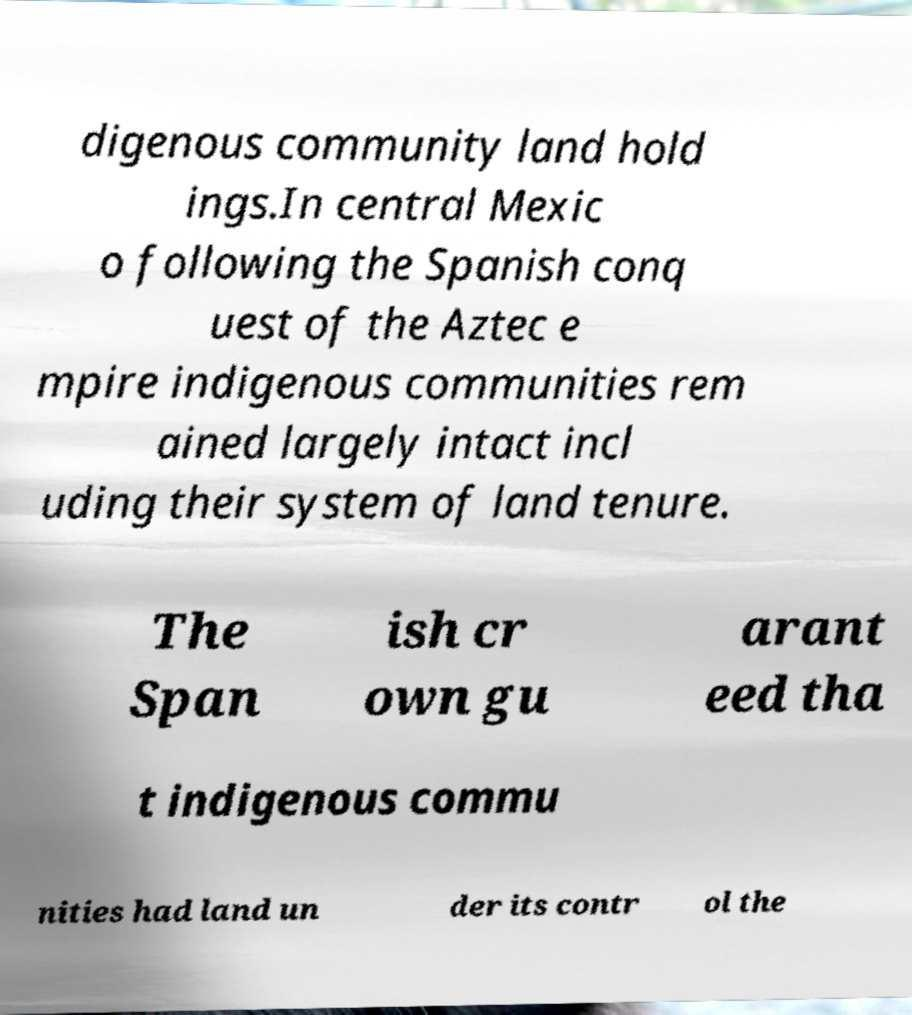Please read and relay the text visible in this image. What does it say? digenous community land hold ings.In central Mexic o following the Spanish conq uest of the Aztec e mpire indigenous communities rem ained largely intact incl uding their system of land tenure. The Span ish cr own gu arant eed tha t indigenous commu nities had land un der its contr ol the 